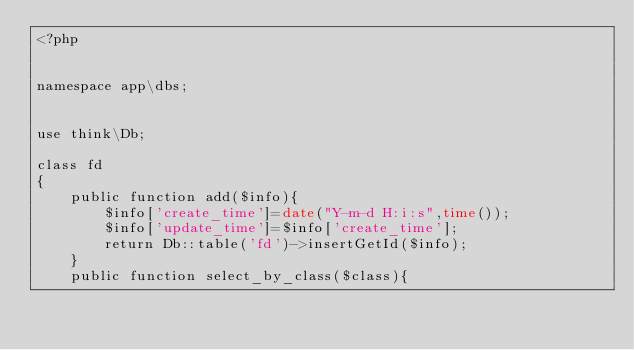<code> <loc_0><loc_0><loc_500><loc_500><_PHP_><?php


namespace app\dbs;


use think\Db;

class fd
{
    public function add($info){
        $info['create_time']=date("Y-m-d H:i:s",time());
        $info['update_time']=$info['create_time'];
        return Db::table('fd')->insertGetId($info);
    }
    public function select_by_class($class){</code> 